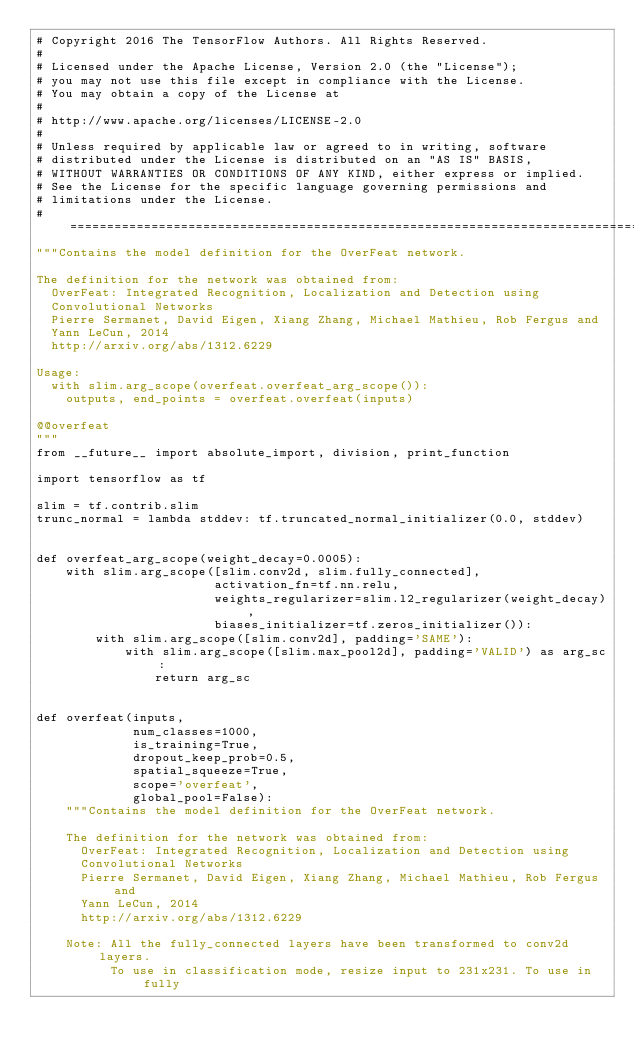Convert code to text. <code><loc_0><loc_0><loc_500><loc_500><_Python_># Copyright 2016 The TensorFlow Authors. All Rights Reserved.
#
# Licensed under the Apache License, Version 2.0 (the "License");
# you may not use this file except in compliance with the License.
# You may obtain a copy of the License at
#
# http://www.apache.org/licenses/LICENSE-2.0
#
# Unless required by applicable law or agreed to in writing, software
# distributed under the License is distributed on an "AS IS" BASIS,
# WITHOUT WARRANTIES OR CONDITIONS OF ANY KIND, either express or implied.
# See the License for the specific language governing permissions and
# limitations under the License.
# ==============================================================================
"""Contains the model definition for the OverFeat network.

The definition for the network was obtained from:
  OverFeat: Integrated Recognition, Localization and Detection using
  Convolutional Networks
  Pierre Sermanet, David Eigen, Xiang Zhang, Michael Mathieu, Rob Fergus and
  Yann LeCun, 2014
  http://arxiv.org/abs/1312.6229

Usage:
  with slim.arg_scope(overfeat.overfeat_arg_scope()):
    outputs, end_points = overfeat.overfeat(inputs)

@@overfeat
"""
from __future__ import absolute_import, division, print_function

import tensorflow as tf

slim = tf.contrib.slim
trunc_normal = lambda stddev: tf.truncated_normal_initializer(0.0, stddev)


def overfeat_arg_scope(weight_decay=0.0005):
    with slim.arg_scope([slim.conv2d, slim.fully_connected],
                        activation_fn=tf.nn.relu,
                        weights_regularizer=slim.l2_regularizer(weight_decay),
                        biases_initializer=tf.zeros_initializer()):
        with slim.arg_scope([slim.conv2d], padding='SAME'):
            with slim.arg_scope([slim.max_pool2d], padding='VALID') as arg_sc:
                return arg_sc


def overfeat(inputs,
             num_classes=1000,
             is_training=True,
             dropout_keep_prob=0.5,
             spatial_squeeze=True,
             scope='overfeat',
             global_pool=False):
    """Contains the model definition for the OverFeat network.

    The definition for the network was obtained from:
      OverFeat: Integrated Recognition, Localization and Detection using
      Convolutional Networks
      Pierre Sermanet, David Eigen, Xiang Zhang, Michael Mathieu, Rob Fergus and
      Yann LeCun, 2014
      http://arxiv.org/abs/1312.6229

    Note: All the fully_connected layers have been transformed to conv2d layers.
          To use in classification mode, resize input to 231x231. To use in fully</code> 